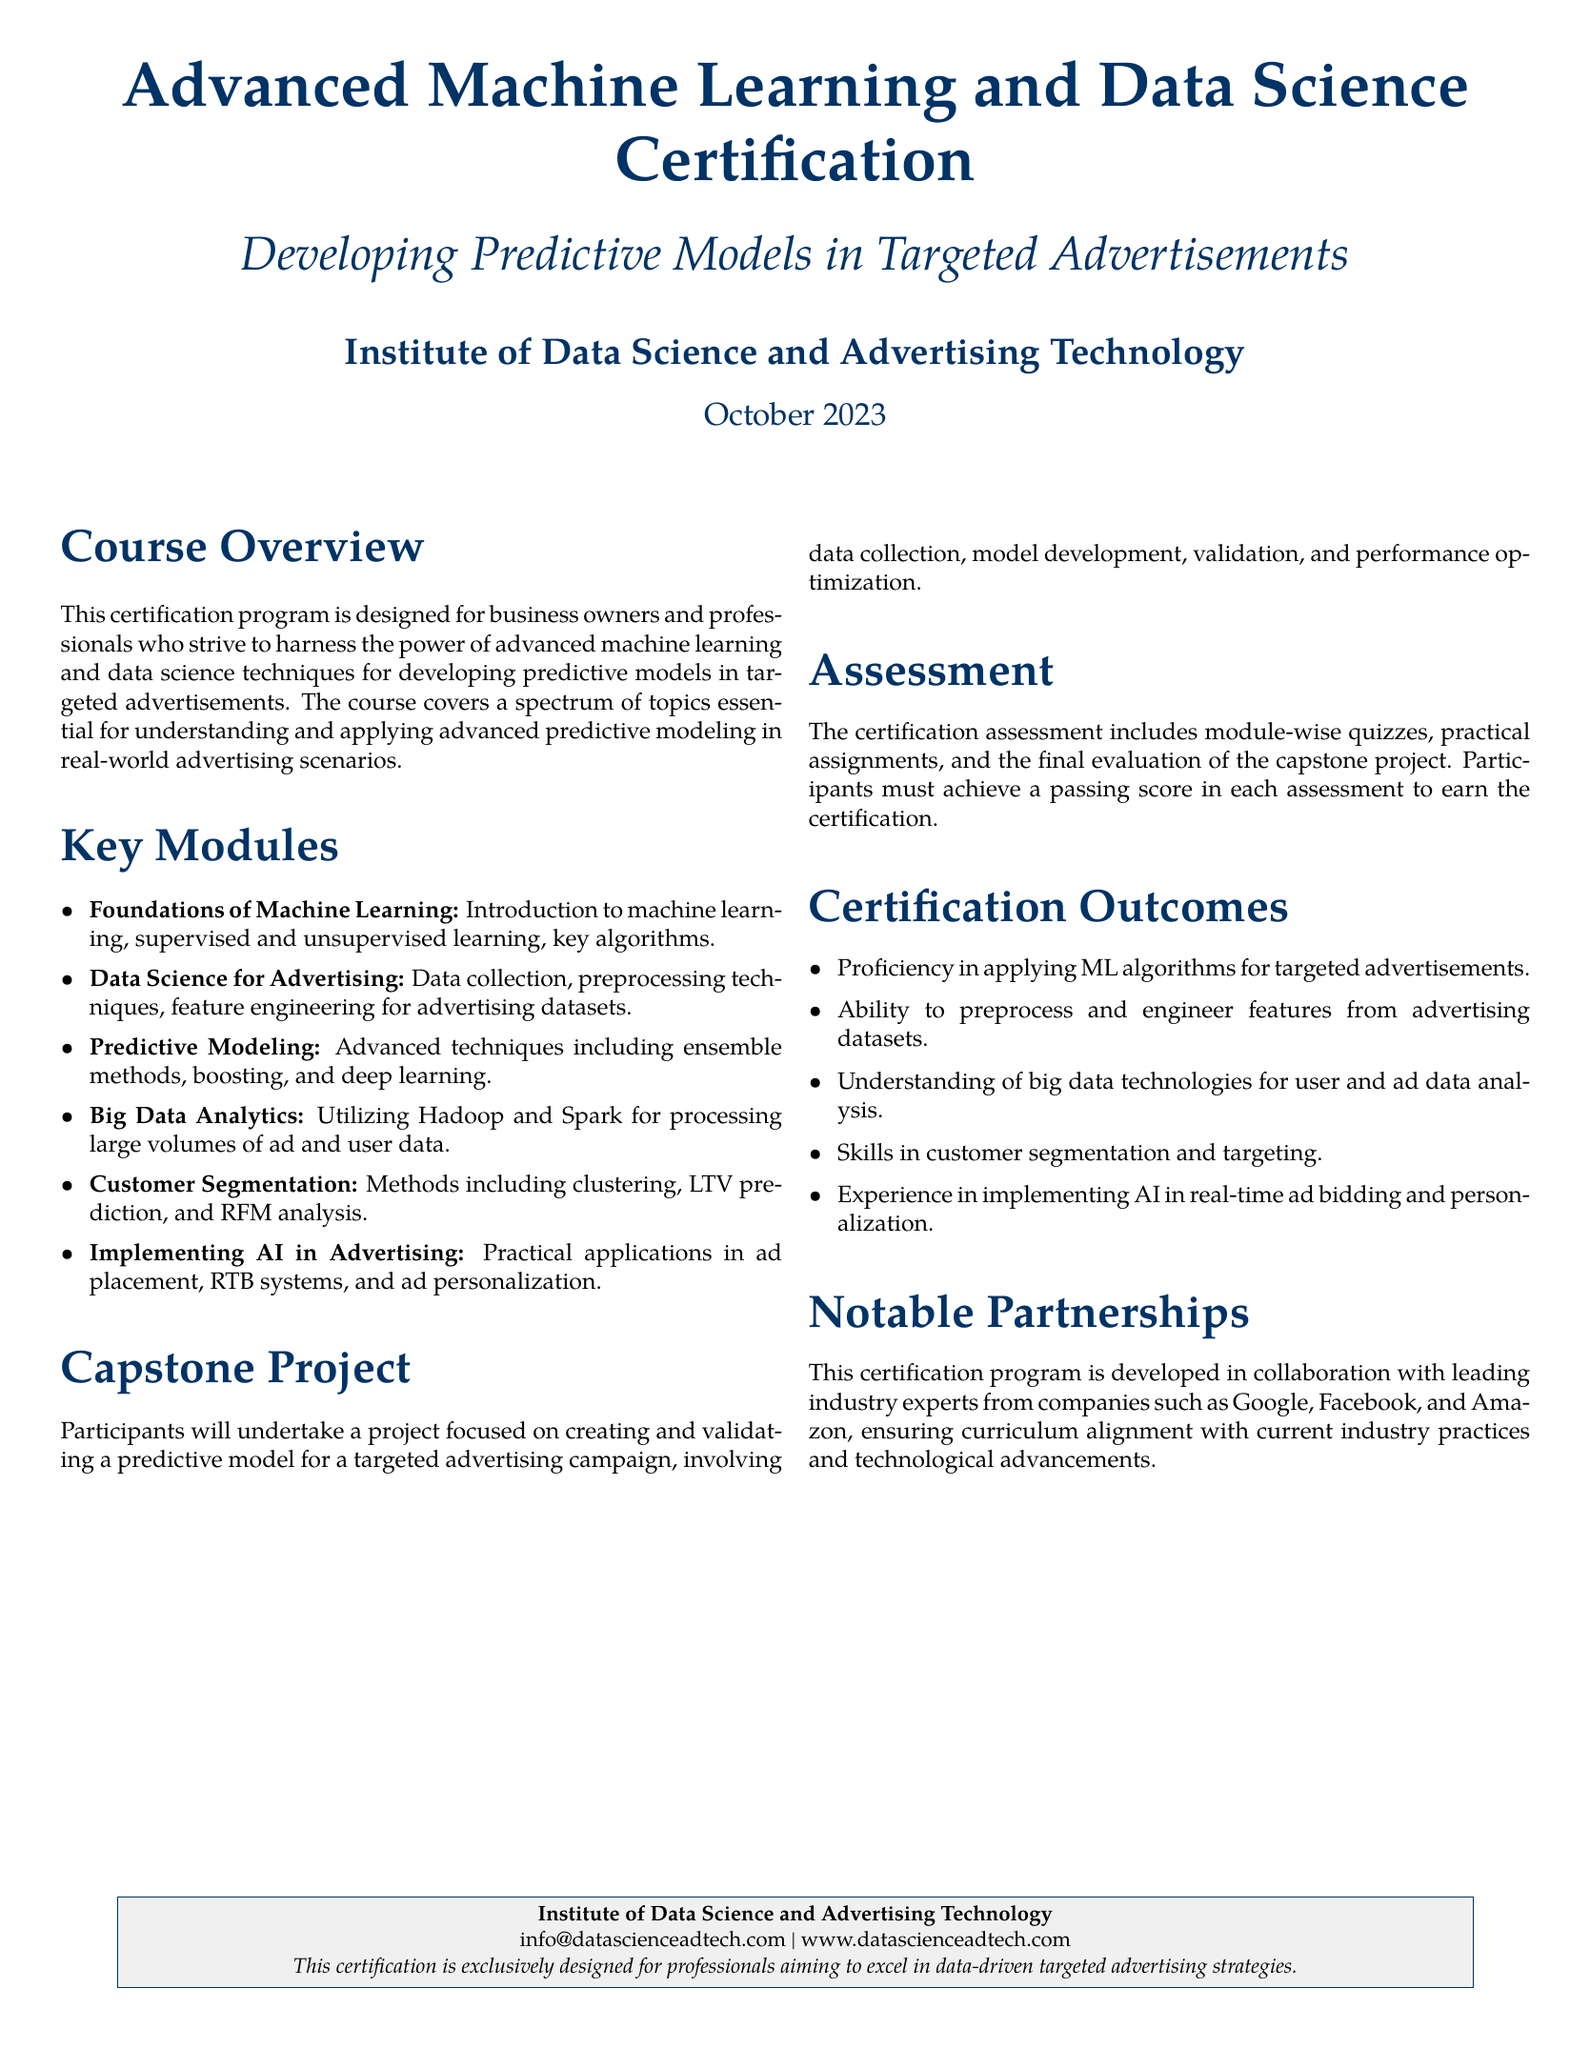What is the name of the certification program? The name of the certification program is stated in the title section of the document.
Answer: Advanced Machine Learning and Data Science Certification What is the date of the certification program? The date is specified at the end of the title section in the document.
Answer: October 2023 What key module covers customer segmentation? This module is listed under the Key Modules section of the document.
Answer: Customer Segmentation Who developed this certification program? The document mentions the collaboration with industry experts.
Answer: Leading industry experts from companies such as Google, Facebook, and Amazon What is one of the skills participants will gain? The document lists the skills achieved through the certification program.
Answer: Ability to preprocess and engineer features from advertising datasets What type of project do participants undertake? The type of project is mentioned in the Capstone Project section.
Answer: Creating and validating a predictive model for a targeted advertising campaign What technologies are covered in Big Data Analytics? The specific technologies are highlighted in the Key Modules section.
Answer: Hadoop and Spark How is the assessment structured? The structure of the assessment is described in the Assessment section of the document.
Answer: Module-wise quizzes, practical assignments, and final evaluation of the capstone project 